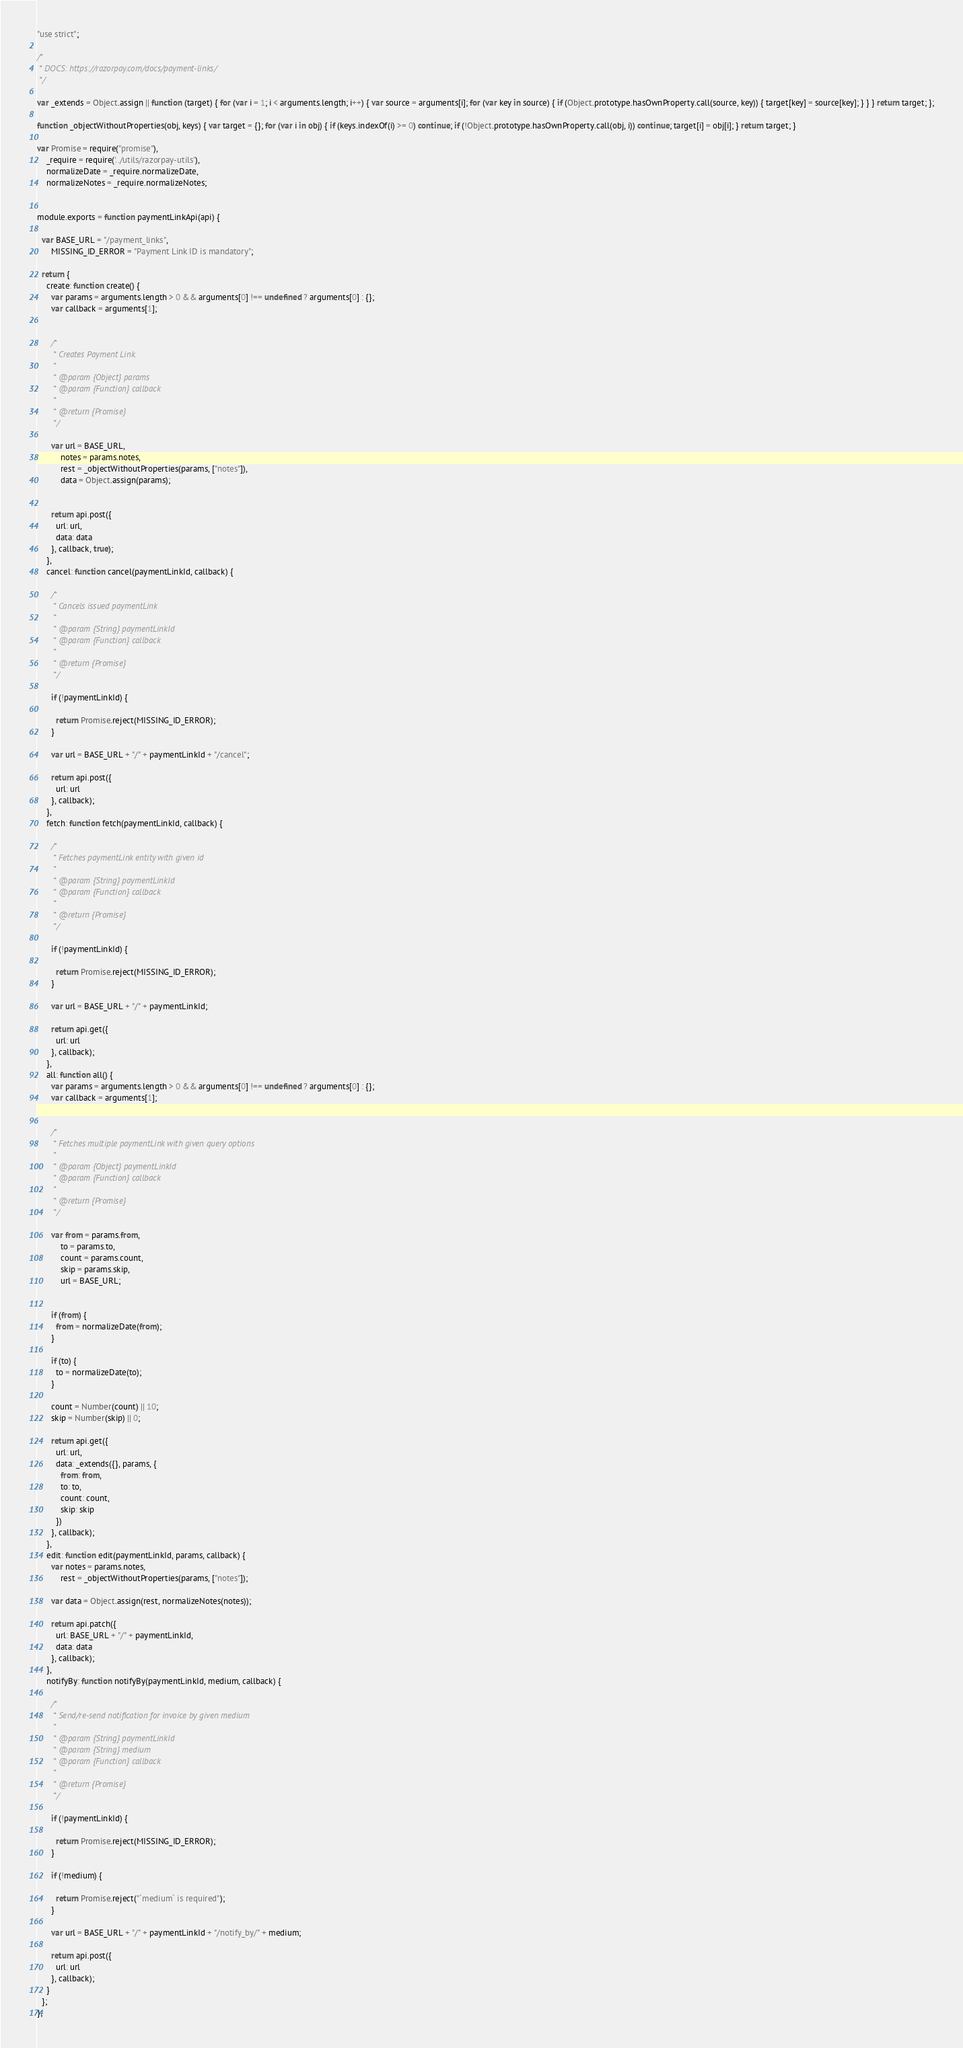<code> <loc_0><loc_0><loc_500><loc_500><_JavaScript_>"use strict";

/*
 * DOCS: https://razorpay.com/docs/payment-links/
 */

var _extends = Object.assign || function (target) { for (var i = 1; i < arguments.length; i++) { var source = arguments[i]; for (var key in source) { if (Object.prototype.hasOwnProperty.call(source, key)) { target[key] = source[key]; } } } return target; };

function _objectWithoutProperties(obj, keys) { var target = {}; for (var i in obj) { if (keys.indexOf(i) >= 0) continue; if (!Object.prototype.hasOwnProperty.call(obj, i)) continue; target[i] = obj[i]; } return target; }

var Promise = require("promise"),
    _require = require('../utils/razorpay-utils'),
    normalizeDate = _require.normalizeDate,
    normalizeNotes = _require.normalizeNotes;


module.exports = function paymentLinkApi(api) {

  var BASE_URL = "/payment_links",
      MISSING_ID_ERROR = "Payment Link ID is mandatory";

  return {
    create: function create() {
      var params = arguments.length > 0 && arguments[0] !== undefined ? arguments[0] : {};
      var callback = arguments[1];


      /*
       * Creates Payment Link.
       *
       * @param {Object} params
       * @param {Function} callback
       *
       * @return {Promise}
       */

      var url = BASE_URL,
          notes = params.notes,
          rest = _objectWithoutProperties(params, ["notes"]),
          data = Object.assign(params);


      return api.post({
        url: url,
        data: data
      }, callback, true);
    },
    cancel: function cancel(paymentLinkId, callback) {

      /*
       * Cancels issued paymentLink
       *
       * @param {String} paymentLinkId
       * @param {Function} callback
       *
       * @return {Promise}
       */

      if (!paymentLinkId) {

        return Promise.reject(MISSING_ID_ERROR);
      }

      var url = BASE_URL + "/" + paymentLinkId + "/cancel";

      return api.post({
        url: url
      }, callback);
    },
    fetch: function fetch(paymentLinkId, callback) {

      /*
       * Fetches paymentLink entity with given id
       *
       * @param {String} paymentLinkId
       * @param {Function} callback
       *
       * @return {Promise}
       */

      if (!paymentLinkId) {

        return Promise.reject(MISSING_ID_ERROR);
      }

      var url = BASE_URL + "/" + paymentLinkId;

      return api.get({
        url: url
      }, callback);
    },
    all: function all() {
      var params = arguments.length > 0 && arguments[0] !== undefined ? arguments[0] : {};
      var callback = arguments[1];


      /*
       * Fetches multiple paymentLink with given query options
       *
       * @param {Object} paymentLinkId
       * @param {Function} callback
       *
       * @return {Promise}
       */

      var from = params.from,
          to = params.to,
          count = params.count,
          skip = params.skip,
          url = BASE_URL;


      if (from) {
        from = normalizeDate(from);
      }

      if (to) {
        to = normalizeDate(to);
      }

      count = Number(count) || 10;
      skip = Number(skip) || 0;

      return api.get({
        url: url,
        data: _extends({}, params, {
          from: from,
          to: to,
          count: count,
          skip: skip
        })
      }, callback);
    },
    edit: function edit(paymentLinkId, params, callback) {
      var notes = params.notes,
          rest = _objectWithoutProperties(params, ["notes"]);

      var data = Object.assign(rest, normalizeNotes(notes));

      return api.patch({
        url: BASE_URL + "/" + paymentLinkId,
        data: data
      }, callback);
    },
    notifyBy: function notifyBy(paymentLinkId, medium, callback) {

      /*
       * Send/re-send notification for invoice by given medium
       * 
       * @param {String} paymentLinkId
       * @param {String} medium
       * @param {Function} callback
       * 
       * @return {Promise}
       */

      if (!paymentLinkId) {

        return Promise.reject(MISSING_ID_ERROR);
      }

      if (!medium) {

        return Promise.reject("`medium` is required");
      }

      var url = BASE_URL + "/" + paymentLinkId + "/notify_by/" + medium;

      return api.post({
        url: url
      }, callback);
    }
  };
};</code> 